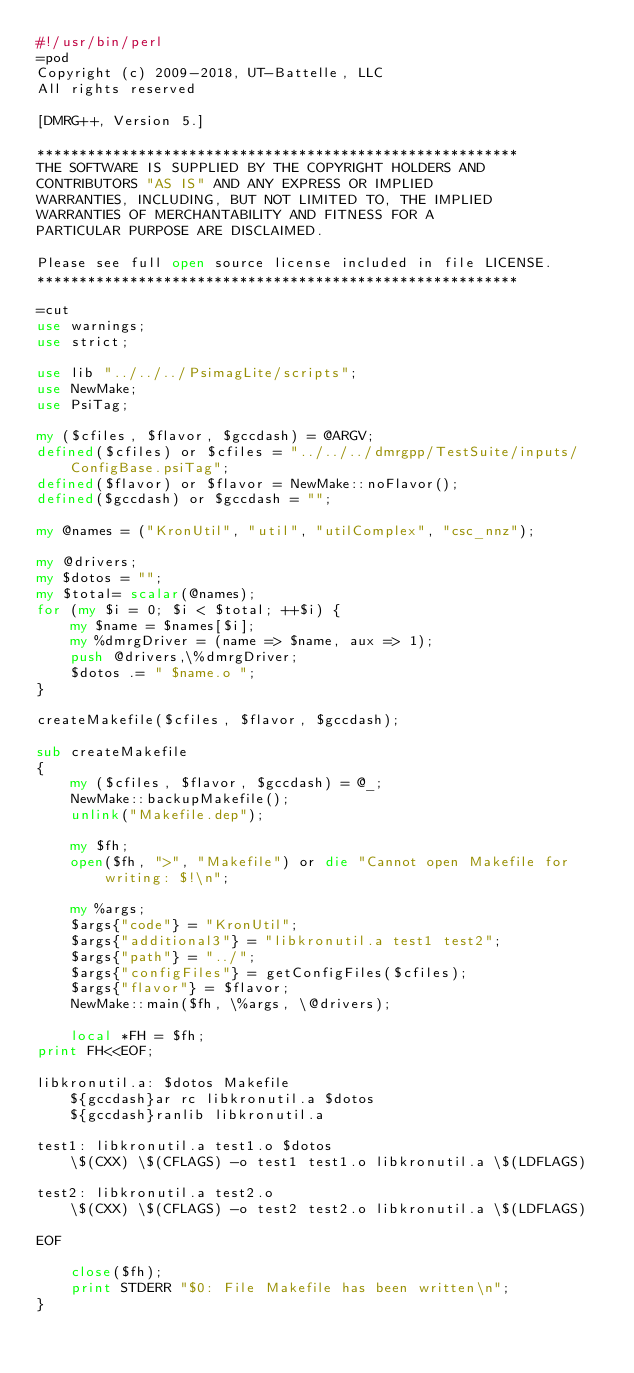Convert code to text. <code><loc_0><loc_0><loc_500><loc_500><_Perl_>#!/usr/bin/perl
=pod
Copyright (c) 2009-2018, UT-Battelle, LLC
All rights reserved

[DMRG++, Version 5.]

*********************************************************
THE SOFTWARE IS SUPPLIED BY THE COPYRIGHT HOLDERS AND
CONTRIBUTORS "AS IS" AND ANY EXPRESS OR IMPLIED
WARRANTIES, INCLUDING, BUT NOT LIMITED TO, THE IMPLIED
WARRANTIES OF MERCHANTABILITY AND FITNESS FOR A
PARTICULAR PURPOSE ARE DISCLAIMED.

Please see full open source license included in file LICENSE.
*********************************************************

=cut
use warnings;
use strict;

use lib "../../../PsimagLite/scripts";
use NewMake;
use PsiTag;

my ($cfiles, $flavor, $gccdash) = @ARGV;
defined($cfiles) or $cfiles = "../../../dmrgpp/TestSuite/inputs/ConfigBase.psiTag";
defined($flavor) or $flavor = NewMake::noFlavor();
defined($gccdash) or $gccdash = "";

my @names = ("KronUtil", "util", "utilComplex", "csc_nnz");

my @drivers;
my $dotos = "";
my $total= scalar(@names);
for (my $i = 0; $i < $total; ++$i) {
	my $name = $names[$i];
	my %dmrgDriver = (name => $name, aux => 1);
	push @drivers,\%dmrgDriver;
	$dotos .= " $name.o ";
}

createMakefile($cfiles, $flavor, $gccdash);

sub createMakefile
{
	my ($cfiles, $flavor, $gccdash) = @_;
	NewMake::backupMakefile();
	unlink("Makefile.dep");

	my $fh;
	open($fh, ">", "Makefile") or die "Cannot open Makefile for writing: $!\n";

	my %args;
	$args{"code"} = "KronUtil";
	$args{"additional3"} = "libkronutil.a test1 test2";
	$args{"path"} = "../";
	$args{"configFiles"} = getConfigFiles($cfiles);
	$args{"flavor"} = $flavor;
	NewMake::main($fh, \%args, \@drivers);

	local *FH = $fh;
print FH<<EOF;

libkronutil.a: $dotos Makefile
	${gccdash}ar rc libkronutil.a $dotos
	${gccdash}ranlib libkronutil.a

test1: libkronutil.a test1.o $dotos
	\$(CXX) \$(CFLAGS) -o test1 test1.o libkronutil.a \$(LDFLAGS)

test2: libkronutil.a test2.o
	\$(CXX) \$(CFLAGS) -o test2 test2.o libkronutil.a \$(LDFLAGS)

EOF

	close($fh);
	print STDERR "$0: File Makefile has been written\n";
}
</code> 